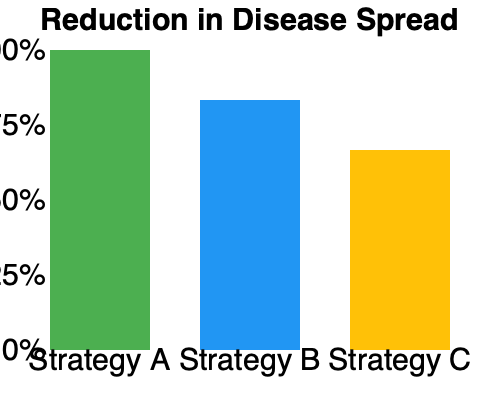Based on the bar chart showing the reduction in disease spread for three different vaccination strategies, which strategy appears to be the most effective, and by approximately what percentage does it reduce disease spread compared to the least effective strategy? To answer this question, we need to analyze the bar chart and compare the heights of the bars representing each vaccination strategy:

1. Strategy A (green bar) shows the highest reduction in disease spread, reaching the 100% mark on the y-axis.
2. Strategy B (blue bar) shows the second-highest reduction, reaching approximately the 75% mark.
3. Strategy C (yellow bar) shows the lowest reduction, reaching about the 50% mark.

To calculate the difference in effectiveness between the most and least effective strategies:

1. Most effective: Strategy A (100% reduction)
2. Least effective: Strategy C (50% reduction)
3. Difference: $100\% - 50\% = 50\%$

Therefore, Strategy A (the most effective) reduces disease spread by approximately 50 percentage points more than Strategy C (the least effective).
Answer: Strategy A; 50 percentage points 